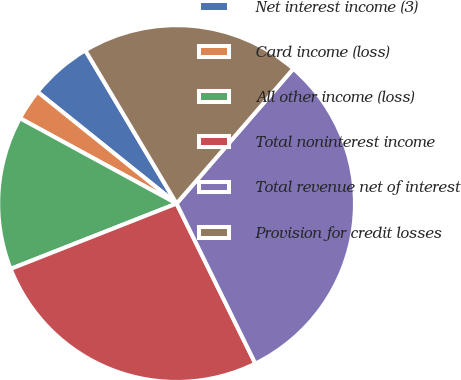<chart> <loc_0><loc_0><loc_500><loc_500><pie_chart><fcel>Net interest income (3)<fcel>Card income (loss)<fcel>All other income (loss)<fcel>Total noninterest income<fcel>Total revenue net of interest<fcel>Provision for credit losses<nl><fcel>5.68%<fcel>2.83%<fcel>13.91%<fcel>26.31%<fcel>31.36%<fcel>19.91%<nl></chart> 